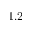Convert formula to latex. <formula><loc_0><loc_0><loc_500><loc_500>\times 1 . 2</formula> 